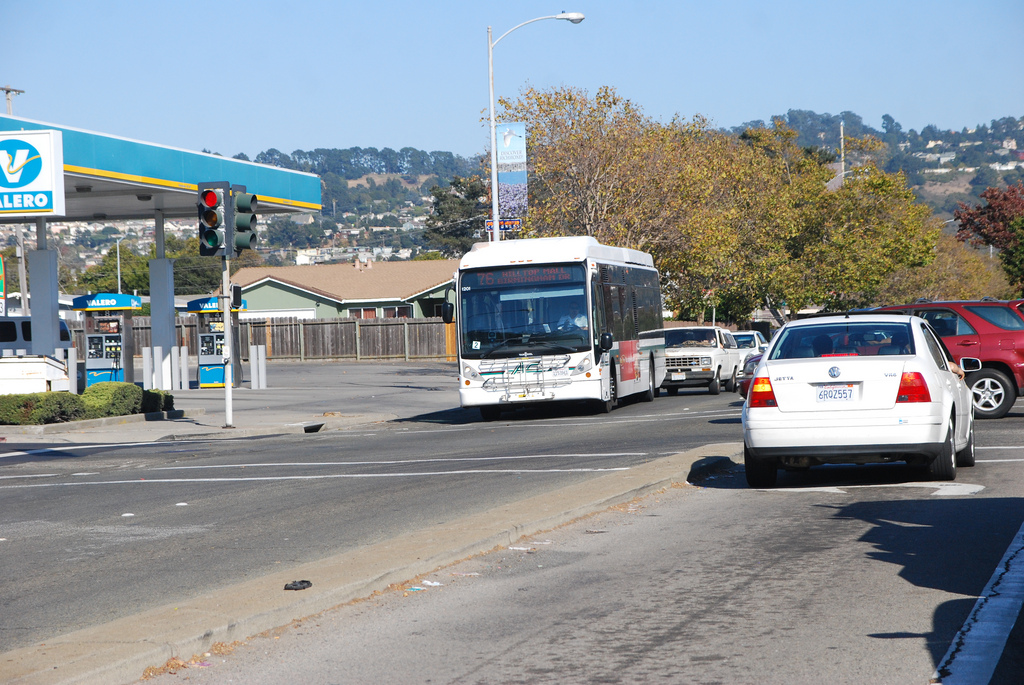What type of vehicle is on the road?
Answer the question using a single word or phrase. Car Is the bus to the right or to the left of the car? Left Is the truck the same color as the gas pump? No Which side is the fence on? Left Is the car to the left or to the right of the fence that is made of wood? Right Are there mirrors in the image? No What color does the fence have? Dark Is the fence that is to the left of the car dark and metallic? No Are there any fences to the left of the car on the road? Yes Is the bus to the right or to the left of the fence on the left? Right Is the person to the left of the vehicle on the road? Yes How is the vehicle to the right of the person that is to the right of the fence called? Car What's the fence made of? Wood On which side of the image is the car? Right Is the person to the right or to the left of the wood fence? Right Is the car to the right or to the left of the bus? Right What vehicle is to the left of the car? Bus Is the gas pump blue? Yes 